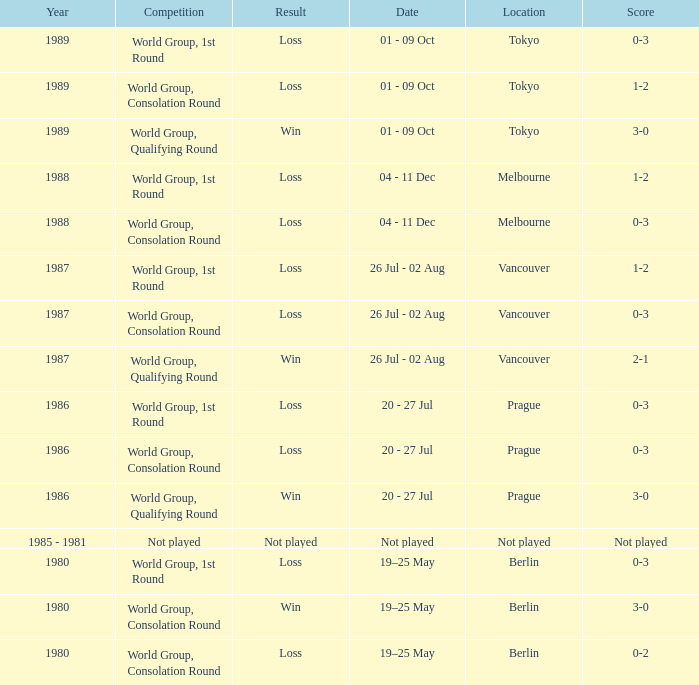What is the year when the date is not played? 1985 - 1981. 